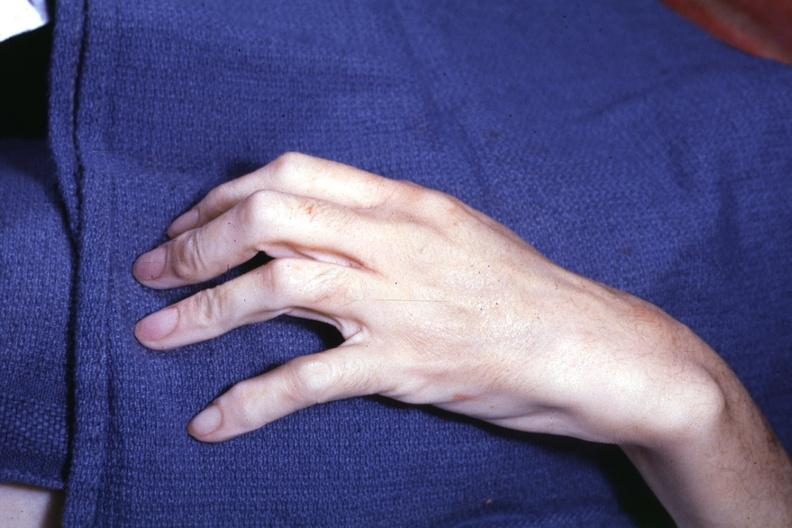s opened dysmorphic body with all organs except kidneys present?
Answer the question using a single word or phrase. No 